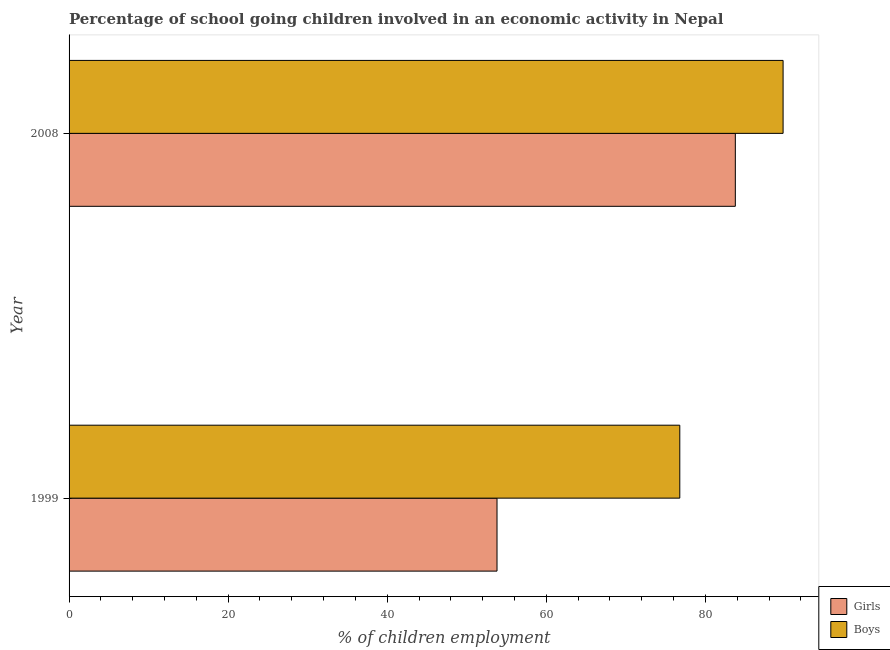Are the number of bars per tick equal to the number of legend labels?
Give a very brief answer. Yes. How many bars are there on the 1st tick from the bottom?
Your response must be concise. 2. What is the label of the 1st group of bars from the top?
Your answer should be very brief. 2008. In how many cases, is the number of bars for a given year not equal to the number of legend labels?
Offer a very short reply. 0. What is the percentage of school going boys in 2008?
Your response must be concise. 89.76. Across all years, what is the maximum percentage of school going boys?
Ensure brevity in your answer.  89.76. Across all years, what is the minimum percentage of school going girls?
Offer a terse response. 53.8. In which year was the percentage of school going girls minimum?
Give a very brief answer. 1999. What is the total percentage of school going girls in the graph?
Your answer should be very brief. 137.56. What is the difference between the percentage of school going girls in 1999 and that in 2008?
Your response must be concise. -29.96. What is the difference between the percentage of school going boys in 2008 and the percentage of school going girls in 1999?
Your answer should be very brief. 35.96. What is the average percentage of school going girls per year?
Your answer should be compact. 68.78. In the year 1999, what is the difference between the percentage of school going girls and percentage of school going boys?
Provide a short and direct response. -22.98. In how many years, is the percentage of school going girls greater than 60 %?
Your response must be concise. 1. What is the ratio of the percentage of school going girls in 1999 to that in 2008?
Ensure brevity in your answer.  0.64. Is the difference between the percentage of school going girls in 1999 and 2008 greater than the difference between the percentage of school going boys in 1999 and 2008?
Provide a short and direct response. No. In how many years, is the percentage of school going girls greater than the average percentage of school going girls taken over all years?
Offer a terse response. 1. What does the 2nd bar from the top in 1999 represents?
Your answer should be very brief. Girls. What does the 2nd bar from the bottom in 1999 represents?
Give a very brief answer. Boys. Are all the bars in the graph horizontal?
Offer a very short reply. Yes. Where does the legend appear in the graph?
Provide a succinct answer. Bottom right. How many legend labels are there?
Your response must be concise. 2. How are the legend labels stacked?
Provide a short and direct response. Vertical. What is the title of the graph?
Your response must be concise. Percentage of school going children involved in an economic activity in Nepal. What is the label or title of the X-axis?
Provide a succinct answer. % of children employment. What is the % of children employment in Girls in 1999?
Provide a succinct answer. 53.8. What is the % of children employment of Boys in 1999?
Your answer should be very brief. 76.78. What is the % of children employment in Girls in 2008?
Provide a short and direct response. 83.76. What is the % of children employment in Boys in 2008?
Ensure brevity in your answer.  89.76. Across all years, what is the maximum % of children employment in Girls?
Provide a short and direct response. 83.76. Across all years, what is the maximum % of children employment in Boys?
Offer a very short reply. 89.76. Across all years, what is the minimum % of children employment of Girls?
Keep it short and to the point. 53.8. Across all years, what is the minimum % of children employment of Boys?
Your response must be concise. 76.78. What is the total % of children employment in Girls in the graph?
Offer a terse response. 137.56. What is the total % of children employment in Boys in the graph?
Make the answer very short. 166.54. What is the difference between the % of children employment in Girls in 1999 and that in 2008?
Your answer should be very brief. -29.96. What is the difference between the % of children employment of Boys in 1999 and that in 2008?
Offer a very short reply. -12.99. What is the difference between the % of children employment of Girls in 1999 and the % of children employment of Boys in 2008?
Provide a succinct answer. -35.96. What is the average % of children employment in Girls per year?
Make the answer very short. 68.78. What is the average % of children employment of Boys per year?
Provide a succinct answer. 83.27. In the year 1999, what is the difference between the % of children employment in Girls and % of children employment in Boys?
Offer a terse response. -22.98. In the year 2008, what is the difference between the % of children employment in Girls and % of children employment in Boys?
Provide a succinct answer. -6. What is the ratio of the % of children employment of Girls in 1999 to that in 2008?
Provide a short and direct response. 0.64. What is the ratio of the % of children employment of Boys in 1999 to that in 2008?
Your answer should be very brief. 0.86. What is the difference between the highest and the second highest % of children employment of Girls?
Keep it short and to the point. 29.96. What is the difference between the highest and the second highest % of children employment in Boys?
Your response must be concise. 12.99. What is the difference between the highest and the lowest % of children employment in Girls?
Keep it short and to the point. 29.96. What is the difference between the highest and the lowest % of children employment of Boys?
Give a very brief answer. 12.99. 